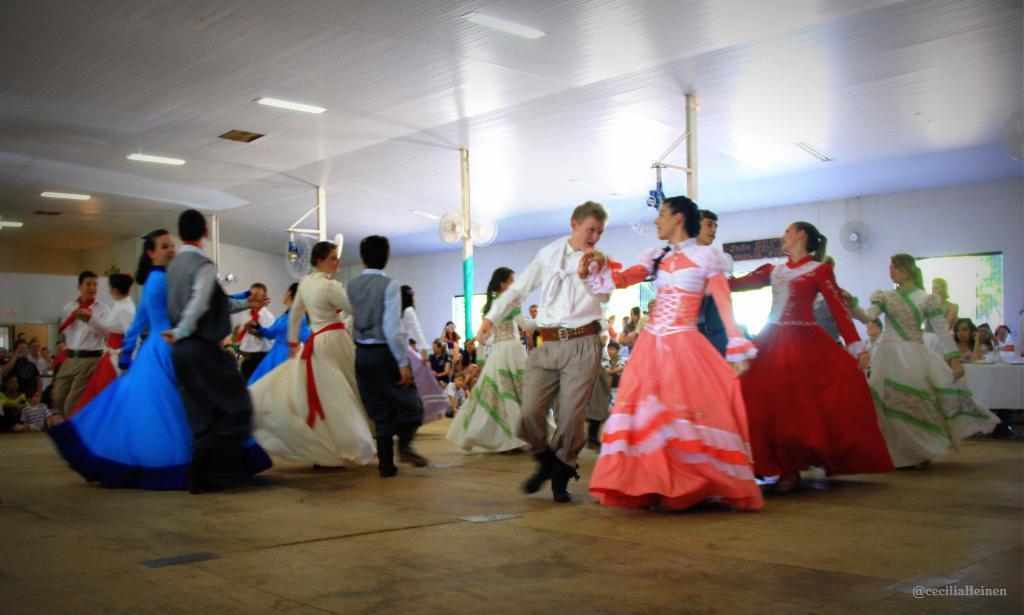Please provide a concise description of this image. In this image in the center there are some people who are dancing, and the background there are some people who are watching them. And at the bottom there is floor in the background there are some windows, wall and also there are some poles fans. And at the top there is ceiling and some lights. 